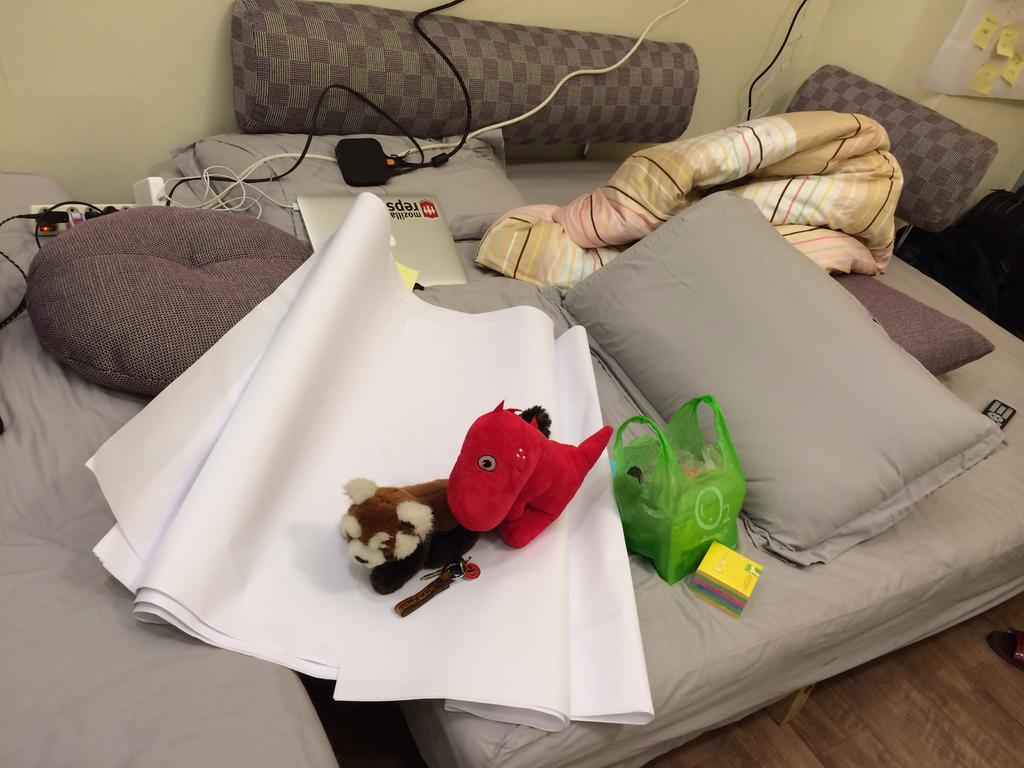Describe this image in one or two sentences. In this picture there is a small bed in the center of the image, on which there are toys, pillows, papers, wires, remote, blanket, polythene are there, it seems to be there is a tab, it seems to be there is a poster in the top right side of the image. 